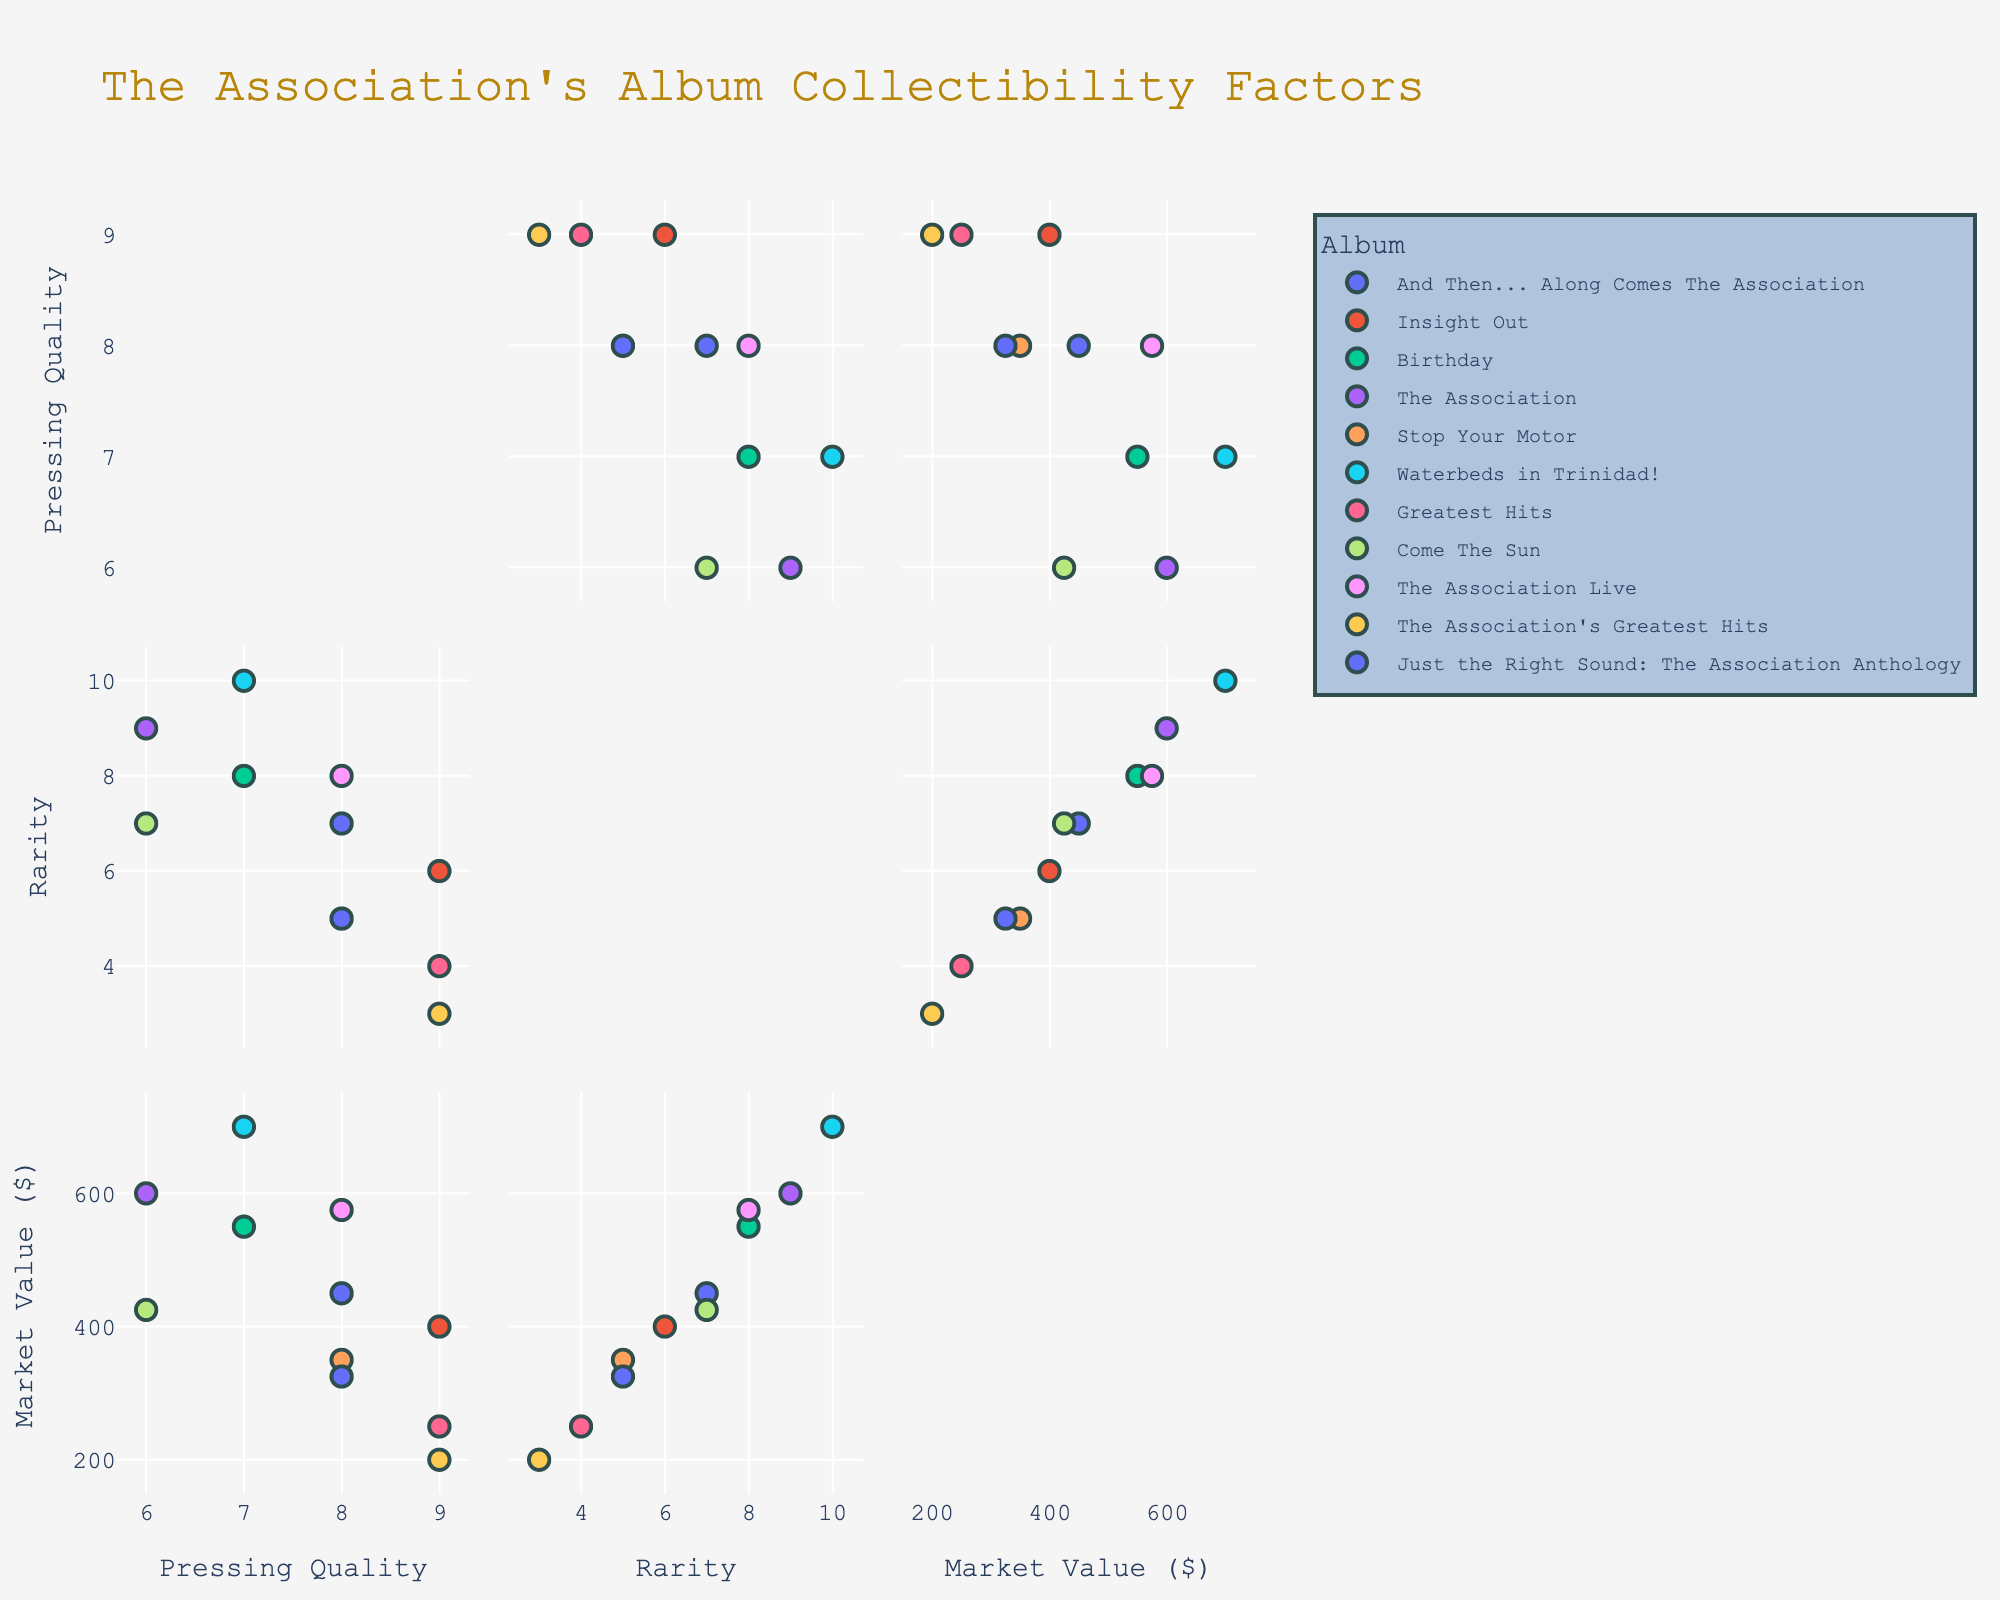What's the title of the figure? The title is usually located at the top of the figure. Here, the title reads "The Association's Album Collectibility Factors."
Answer: The Association's Album Collectibility Factors How many variables are visualized in this scatterplot matrix? Each dimension or variable represents a column from the dataset. Here, we have "Pressing Quality," "Rarity," and "Market Value."
Answer: 3 Which album has the highest market value? In the scatterplot matrix, look along the Market Value axis to find the highest point; this is where "Waterbeds in Trinidad!" stands out.
Answer: Waterbeds in Trinidad! Is there a positive correlation between Rarity and Market Value? Check the scatterplot for the Rarity-Market Value combination. If most dots trend upwards to the right, there's a positive correlation. Here, it appears so.
Answer: Yes Which two albums have the same pressing quality and rarity? Look for overlapping points (dots) on the Pressing Quality and Rarity dimensions. "Just the Right Sound: The Association Anthology" and "Stop Your Motor" both share a Pressing Quality of 8 and Rarity of 5.
Answer: Just the Right Sound: The Association Anthology and Stop Your Motor How does the Pressing Quality of "Insight Out" compare to "Greatest Hits"? Look for these two albums in the Pressing Quality dimension. "Insight Out" has a higher Pressing Quality (9) compared to "Greatest Hits" (9).
Answer: Insight Out has higher Pressing Quality What's the difference in Market Value between "The Association" and "The Association's Greatest Hits"? Check the Market Value axis for both albums. "The Association" has a Market Value of 600, while "The Association’s Greatest Hits" is 200. The difference is 600 - 200 = 400.
Answer: 400 Is there any album with the same Pressing Quality but different Rarity? Look vertically along the Pressing Quality axis for points that are aligned but at different heights. "Greatest Hits" (Rarity 4) and "Just the Right Sound: The Association Anthology" (Rarity 5) both have a Pressing Quality of 9.
Answer: Yes Which album has the lowest pressing quality? Look for the lowest value on the Pressing Quality dimension. "The Association" and "Come The Sun" both have the lowest Pressing Quality, which is 6.
Answer: The Association and Come The Sun What is the average market value of the albums? Add all Market Value entries and divide by the number of albums: (450 + 400 + 550 + 600 + 350 + 700 + 250 + 425 + 575 + 200 + 325) / 11 = 4825 / 11 ≈ 438.64
Answer: ≈ 438.64 